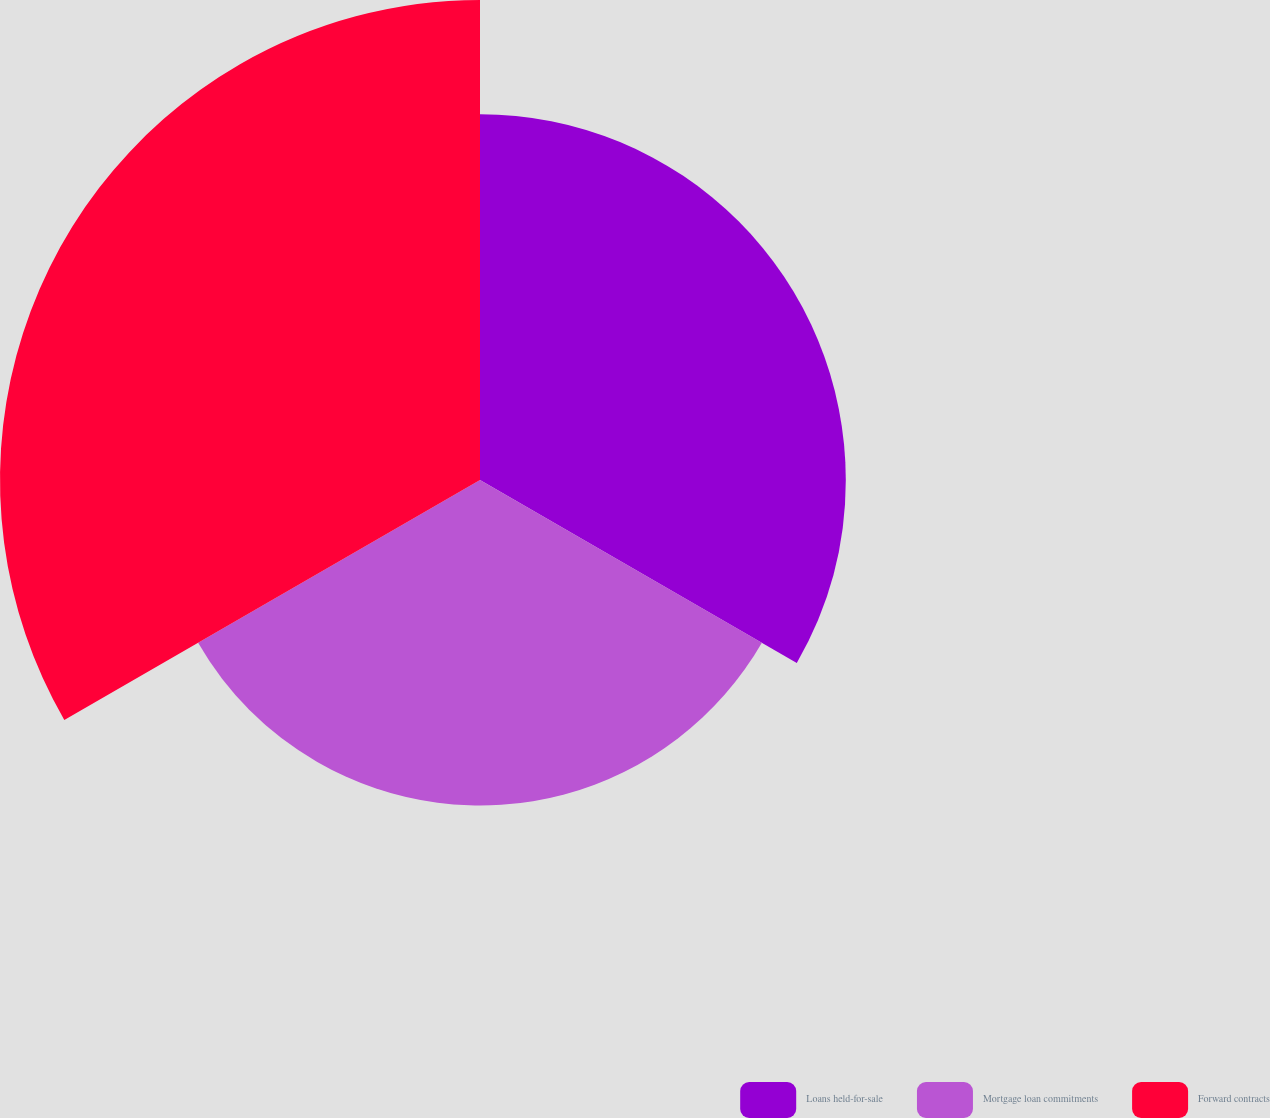<chart> <loc_0><loc_0><loc_500><loc_500><pie_chart><fcel>Loans held-for-sale<fcel>Mortgage loan commitments<fcel>Forward contracts<nl><fcel>31.23%<fcel>27.79%<fcel>40.98%<nl></chart> 